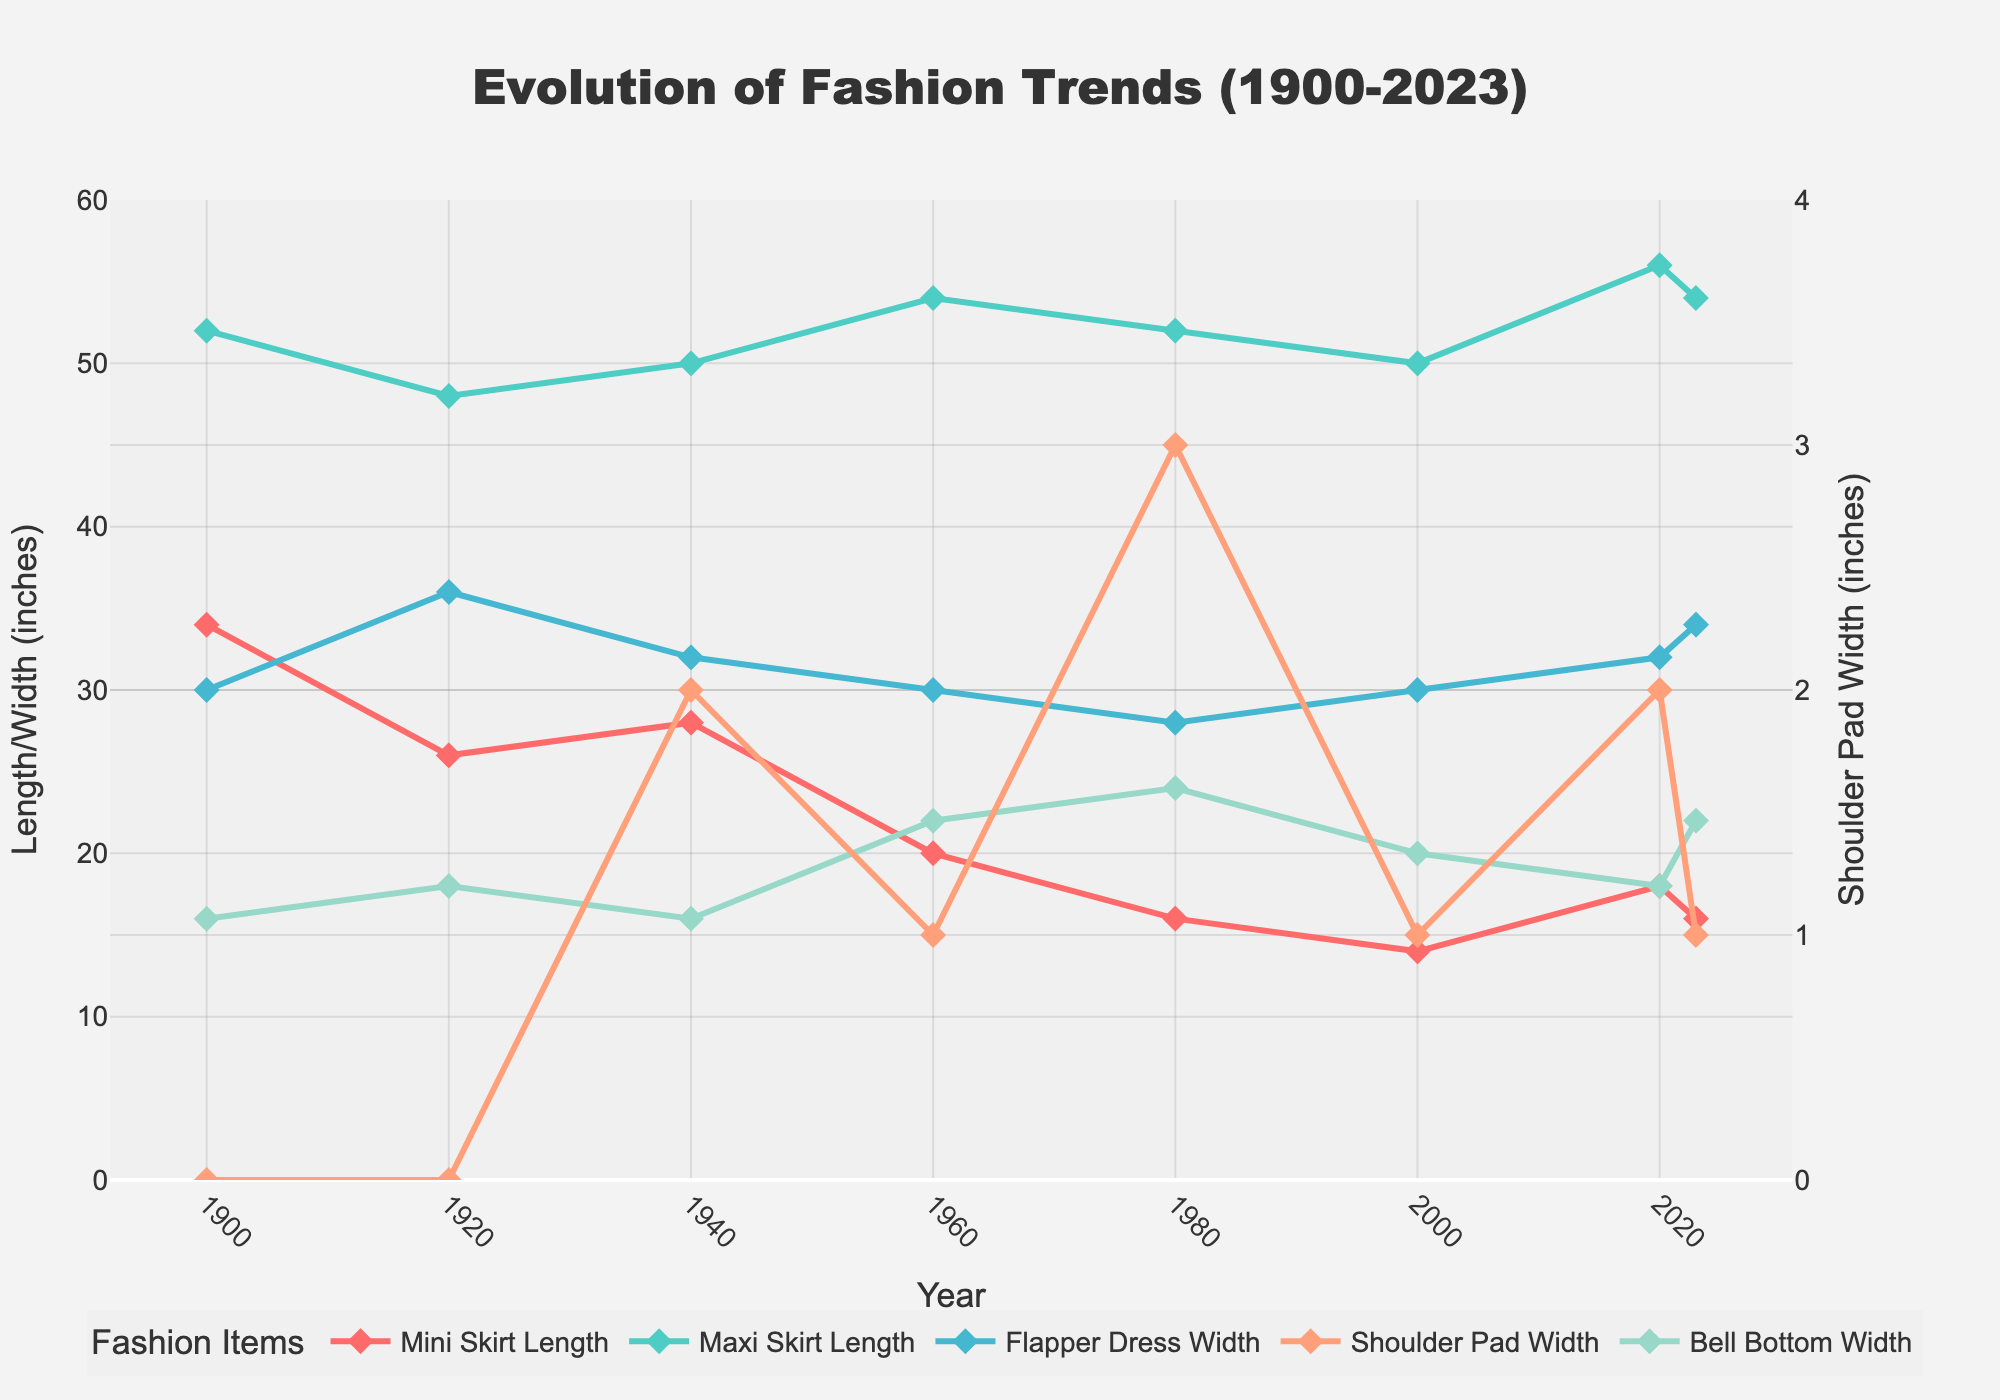What was the trend in mini skirt length between 1900 and 1980? From 1900 to 1920, the mini skirt length decreased from 34 inches to 26 inches. This declining trend continued, reaching 20 inches by 1960, and further down to 16 inches by 1980.
Answer: Decrease When did the flapper dress width reach its maximum value? The flapper dress width peaked at 36 inches in 1920.
Answer: 1920 Compare the shoulder pad width in 1940 and 1980. Which year had the higher value? In 1940, the shoulder pad width was 2 inches, while in 1980, it was 3 inches.
Answer: 1980 What is the median value for maxi skirt length from 1900 to 2023? The values for maxi skirt length are: 52, 48, 50, 54, 52, 50, 56, and 54 inches. Arranging these in order: 48, 50, 50, 52, 52, 54, 54, and 56, the median is the average of the 4th and 5th values: (52+52)/2 = 52 inches.
Answer: 52 inches Which item showed the highest increase in its width/length from 2000 to 2020? Comparing the differences from 2000 to 2020: Mini skirt length: 4 inches, Maxi skirt length: 6 inches, Flapper dress width: 2 inches, Shoulder pad width: 1 inch, Bell bottom width: 2 inches. Thus, maxi skirt length had the largest increase.
Answer: Maxi skirt length In which year did the bell bottom width peak? Bell bottom width peaked at 24 inches in 1980.
Answer: 1980 What has been the general trend in the maxi skirt length from 1900 to 2023? The maxi skirt length fluctuated but generally increased: from 52 inches (1900) to 48 inches (1920), reaching 50 inches (1940), then 54 inches (1960), 52 inches (1980), back to 50 inches (2000), and peaking at 56 inches (2020), and finally 54 inches in 2023.
Answer: Increase How does the mini skirt length in 2020 compare to 1920? In 2020, the mini skirt length was 18 inches, whereas in 1920 it was 26 inches.
Answer: Shorter in 2020 What is the average width of shoulder pads from 1900 to 2023? The values for shoulder pad width are: 0, 0, 2, 1, 3, 1, 2, and 1 inches. The sum is 10, and there are 8 values. Therefore, the average is 10/8 = 1.25 inches.
Answer: 1.25 inches 